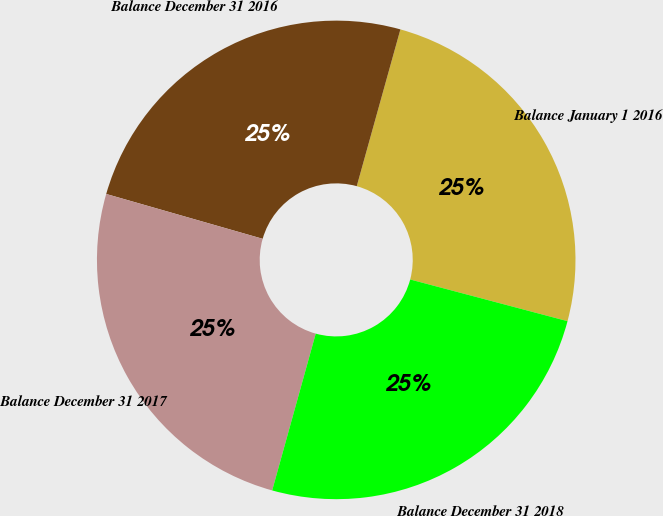Convert chart. <chart><loc_0><loc_0><loc_500><loc_500><pie_chart><fcel>Balance January 1 2016<fcel>Balance December 31 2016<fcel>Balance December 31 2017<fcel>Balance December 31 2018<nl><fcel>24.8%<fcel>24.88%<fcel>25.13%<fcel>25.19%<nl></chart> 